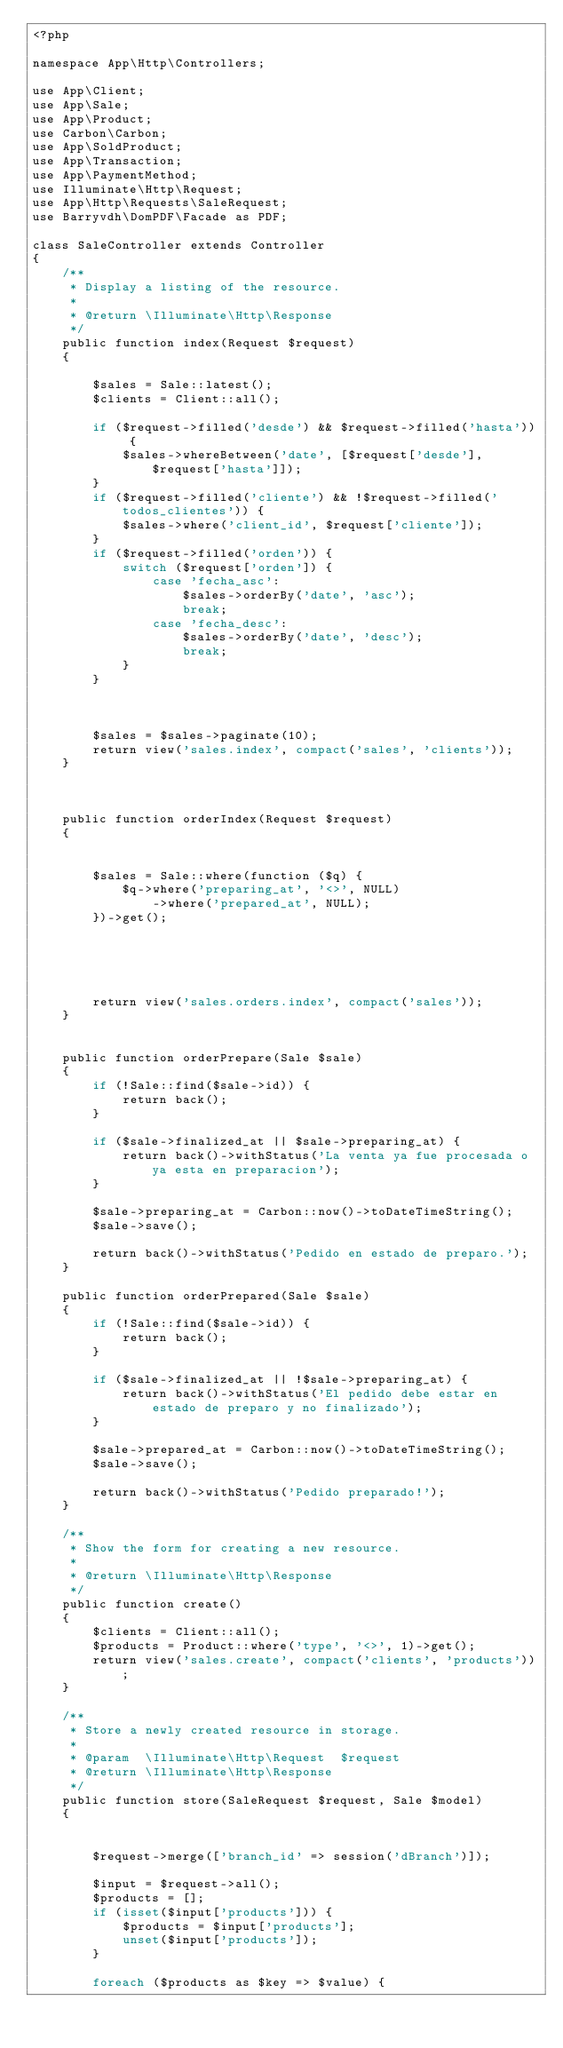Convert code to text. <code><loc_0><loc_0><loc_500><loc_500><_PHP_><?php

namespace App\Http\Controllers;

use App\Client;
use App\Sale;
use App\Product;
use Carbon\Carbon;
use App\SoldProduct;
use App\Transaction;
use App\PaymentMethod;
use Illuminate\Http\Request;
use App\Http\Requests\SaleRequest;
use Barryvdh\DomPDF\Facade as PDF;

class SaleController extends Controller
{
    /**
     * Display a listing of the resource.
     *
     * @return \Illuminate\Http\Response
     */
    public function index(Request $request)
    {

        $sales = Sale::latest();
        $clients = Client::all();

        if ($request->filled('desde') && $request->filled('hasta')) {
            $sales->whereBetween('date', [$request['desde'], $request['hasta']]);
        }
        if ($request->filled('cliente') && !$request->filled('todos_clientes')) {
            $sales->where('client_id', $request['cliente']);
        }
        if ($request->filled('orden')) {
            switch ($request['orden']) {
                case 'fecha_asc':
                    $sales->orderBy('date', 'asc');
                    break;
                case 'fecha_desc':
                    $sales->orderBy('date', 'desc');
                    break;
            }
        }



        $sales = $sales->paginate(10);
        return view('sales.index', compact('sales', 'clients'));
    }



    public function orderIndex(Request $request)
    {


        $sales = Sale::where(function ($q) {
            $q->where('preparing_at', '<>', NULL)
                ->where('prepared_at', NULL);
        })->get();





        return view('sales.orders.index', compact('sales'));
    }


    public function orderPrepare(Sale $sale)
    {
        if (!Sale::find($sale->id)) {
            return back();
        }

        if ($sale->finalized_at || $sale->preparing_at) {
            return back()->withStatus('La venta ya fue procesada o ya esta en preparacion');
        }

        $sale->preparing_at = Carbon::now()->toDateTimeString();
        $sale->save();

        return back()->withStatus('Pedido en estado de preparo.');
    }

    public function orderPrepared(Sale $sale)
    {
        if (!Sale::find($sale->id)) {
            return back();
        }

        if ($sale->finalized_at || !$sale->preparing_at) {
            return back()->withStatus('El pedido debe estar en estado de preparo y no finalizado');
        }

        $sale->prepared_at = Carbon::now()->toDateTimeString();
        $sale->save();

        return back()->withStatus('Pedido preparado!');
    }

    /**
     * Show the form for creating a new resource.
     *
     * @return \Illuminate\Http\Response
     */
    public function create()
    {
        $clients = Client::all();
        $products = Product::where('type', '<>', 1)->get();
        return view('sales.create', compact('clients', 'products'));
    }

    /**
     * Store a newly created resource in storage.
     *
     * @param  \Illuminate\Http\Request  $request
     * @return \Illuminate\Http\Response
     */
    public function store(SaleRequest $request, Sale $model)
    {


        $request->merge(['branch_id' => session('dBranch')]);

        $input = $request->all();
        $products = [];
        if (isset($input['products'])) {
            $products = $input['products'];
            unset($input['products']);
        }

        foreach ($products as $key => $value) {</code> 